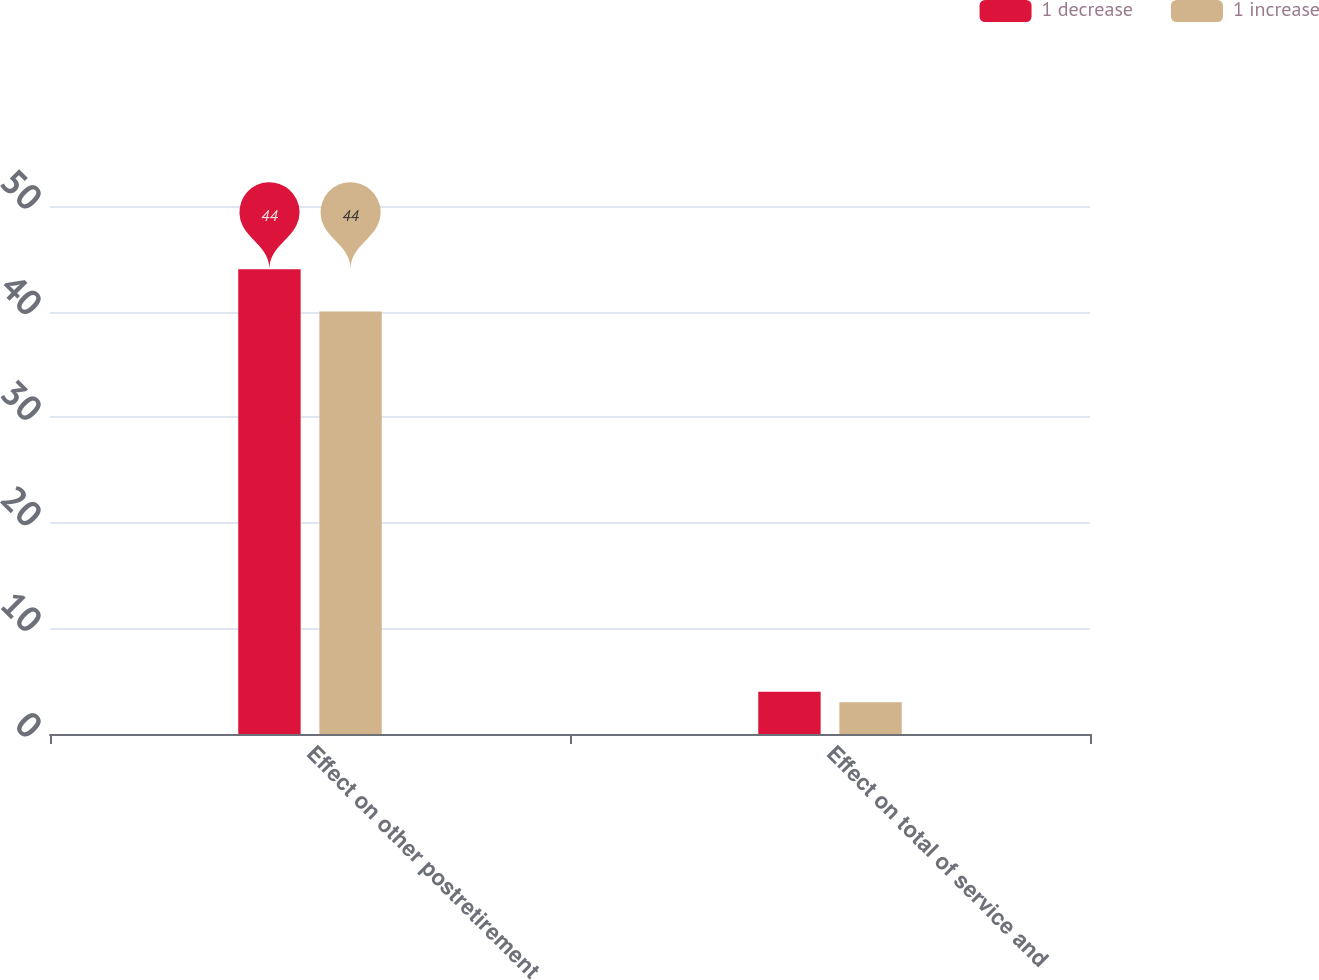<chart> <loc_0><loc_0><loc_500><loc_500><stacked_bar_chart><ecel><fcel>Effect on other postretirement<fcel>Effect on total of service and<nl><fcel>1 decrease<fcel>44<fcel>4<nl><fcel>1 increase<fcel>40<fcel>3<nl></chart> 